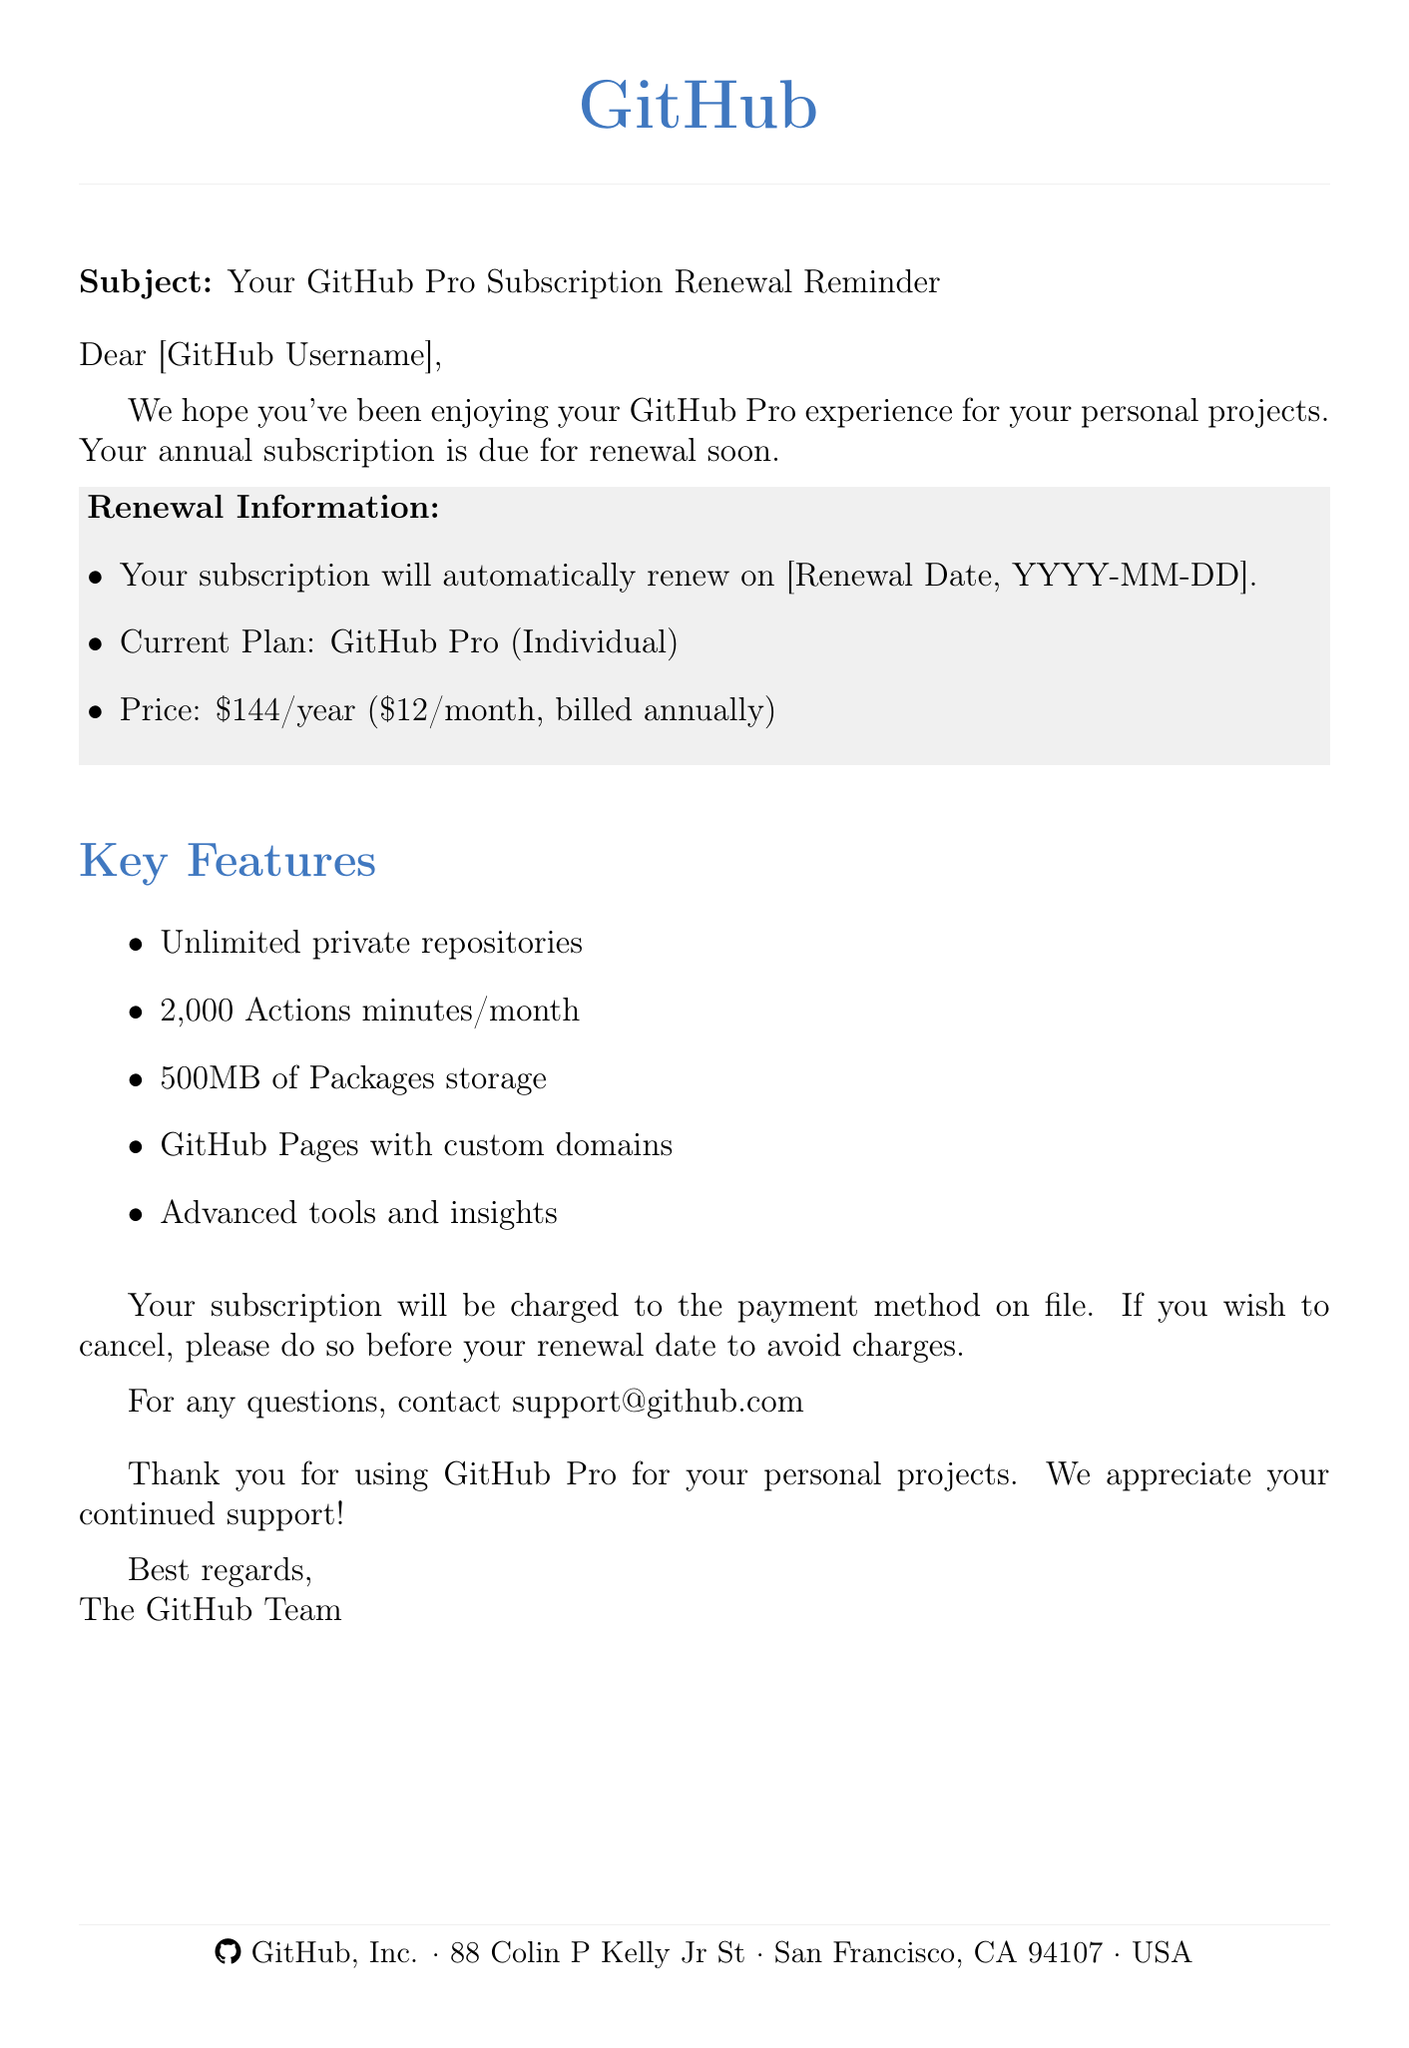What is the subject of the email? The subject line clearly states the purpose of the email regarding the subscription.
Answer: Your GitHub Pro Subscription Renewal Reminder When is the subscription renewal date? The document mentions that the renewal date is specified and is part of the key information.
Answer: [Renewal Date, YYYY-MM-DD] What is the current plan type mentioned? The document indicates the current subscription plan in the renewal information section.
Answer: GitHub Pro (Individual) What is the annual subscription price? The email provides specific pricing detail in terms of annual cost.
Answer: $144/year How many Actions minutes are included per month? The document details a specific feature regarding usage limits for Actions minutes.
Answer: 2,000 Actions minutes/month What should you do if you want to cancel the subscription? The email advises cancellation actions to avoid charges before the renewal date.
Answer: Cancel before your renewal date What is the equivalent monthly pricing when billed annually? The document gives a breakdown of the effective monthly cost when paid annually.
Answer: $12/month (billed annually) Who should you contact for support? The email provides a contact for any queries related to the subscription service.
Answer: support@github.com What is stated as a key feature of GitHub Pro? The document outlines several key features, giving insight into the benefits of the subscription.
Answer: Unlimited private repositories 